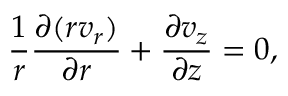<formula> <loc_0><loc_0><loc_500><loc_500>\frac { 1 } { r } \frac { \partial ( r v _ { r } ) } { \partial r } + \frac { \partial v _ { z } } { \partial z } = 0 ,</formula> 